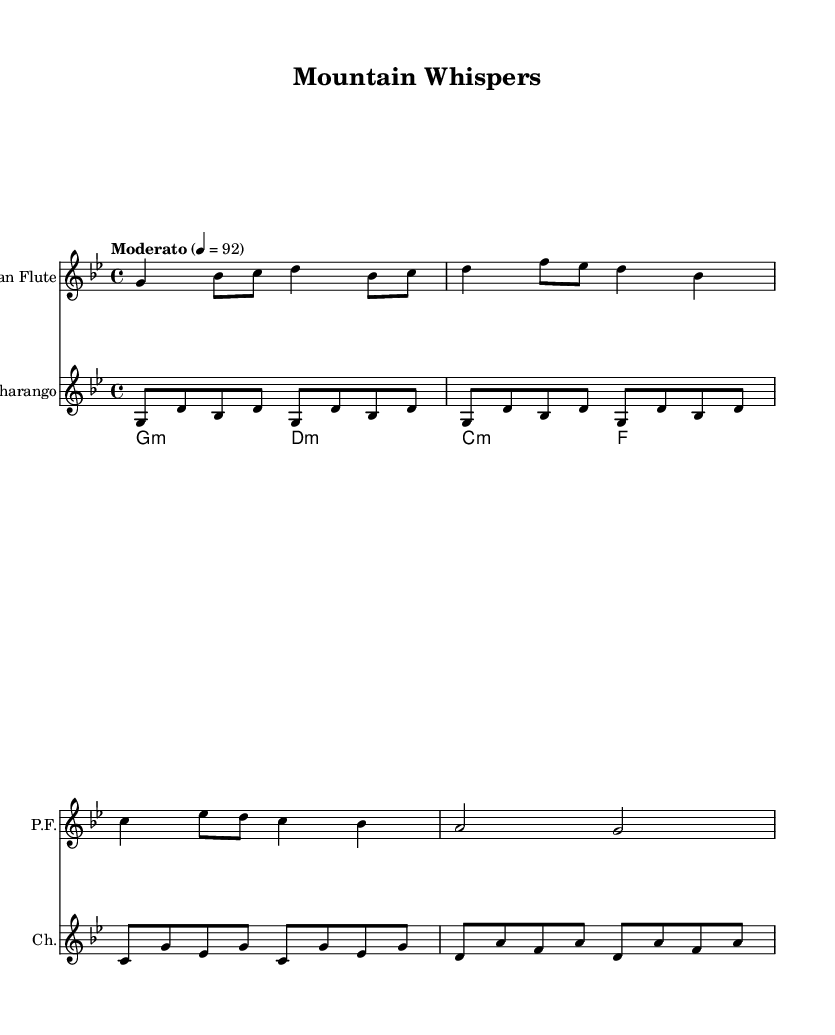What is the key signature of this music? The key signature is indicated at the beginning of the staff with a flat on the 2nd line, which corresponds to B flat. This indicates that B flat is the only sharp present, confirming that the key is G minor, as this key features two flats (B flat and E flat).
Answer: G minor What is the time signature of this music? The time signature is noted at the beginning of the score and appears as "4/4". This means there are four beats in a measure and the quarter note gets one beat. Therefore, measurements are grouped into fours, indicating the rhythm structure of the piece.
Answer: 4/4 What is the tempo indication for this piece? The tempo indication is found at the beginning of the score, where it states "Moderato" and is written as a metronome marking of 92 beats per minute. This establishes the speed at which the piece should be played.
Answer: Moderato Which instruments are featured in this score? Each instrument is labeled at the beginning of its respective staff. The first staff is labeled "Pan Flute" and the second staff is labeled "Charango". These designations directly identify the instruments that perform the notated music.
Answer: Pan Flute and Charango How many measures are there in the pan flute part? By counting the measure lines throughout the pan flute part, you can assess the total number of measures. In this specific example, there are 4 measures in total, which encompass the entire length of the notated music for that instrument.
Answer: 4 What are the first four notes of the charango? Reviewing the charango part on the music sheet reveals that the first four notes are written in sequence as "G, D, B flat, D". Each note appears in ascending order at the beginning of the staff, confirming their technical notation.
Answer: G, D, B flat, D What type of chords are used in the charango chords section? The chord mode section presents a "minor" indication (denoted as m) for both G and D chords. This suggests a tonal quality characterized by a melancholy or somber feel often associated with minor chords.
Answer: Minor 